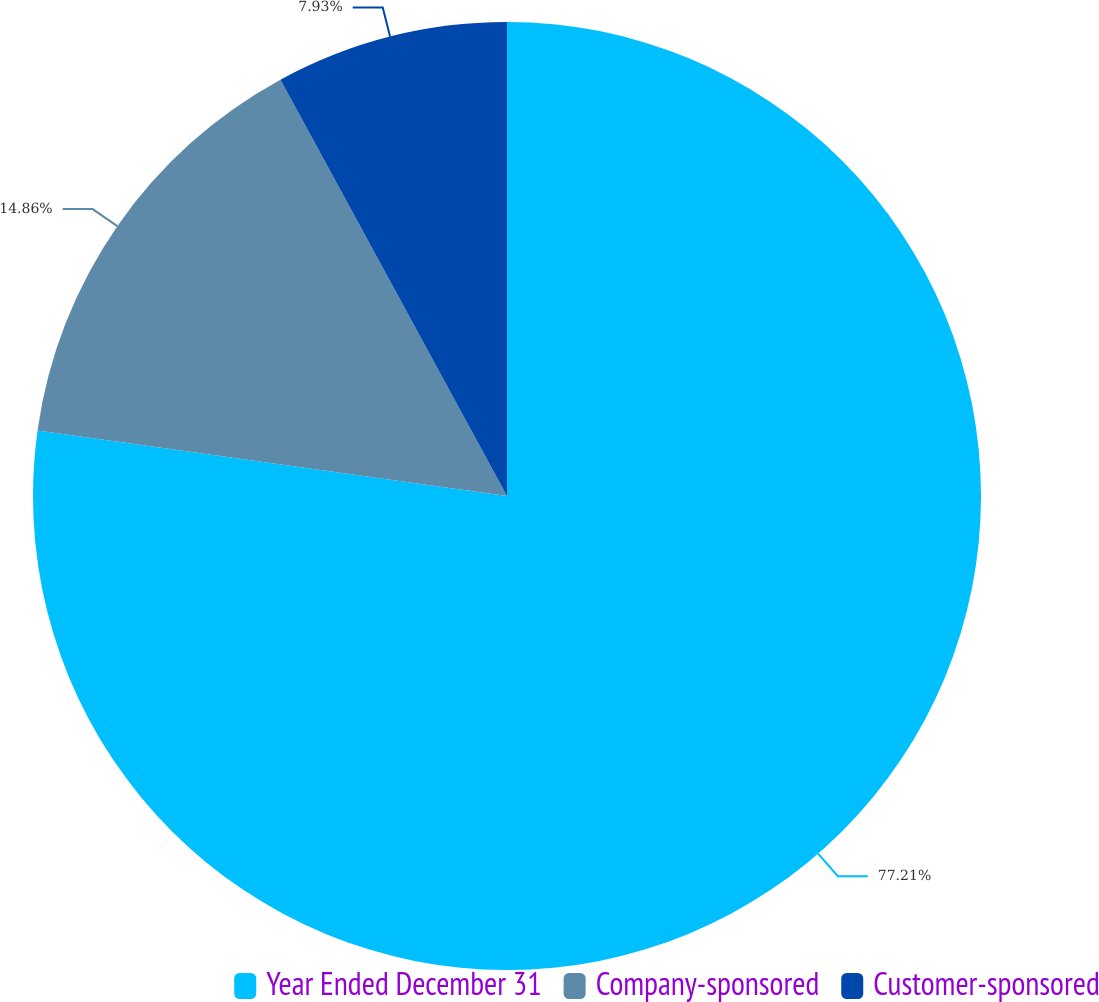Convert chart. <chart><loc_0><loc_0><loc_500><loc_500><pie_chart><fcel>Year Ended December 31<fcel>Company-sponsored<fcel>Customer-sponsored<nl><fcel>77.21%<fcel>14.86%<fcel>7.93%<nl></chart> 